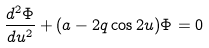Convert formula to latex. <formula><loc_0><loc_0><loc_500><loc_500>\frac { d ^ { 2 } \Phi } { d u ^ { 2 } } + ( a - 2 q \cos 2 u ) \Phi = 0</formula> 